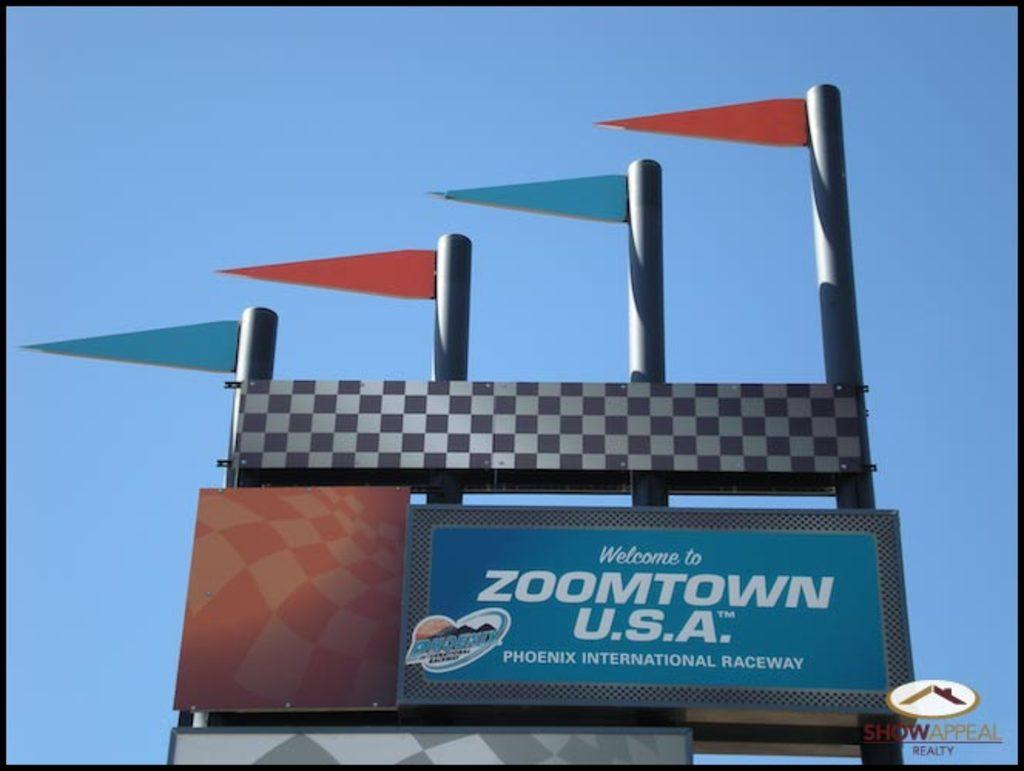<image>
Relay a brief, clear account of the picture shown. A race track sign with flags that says Welcome to Zoomtown U.S.A. 